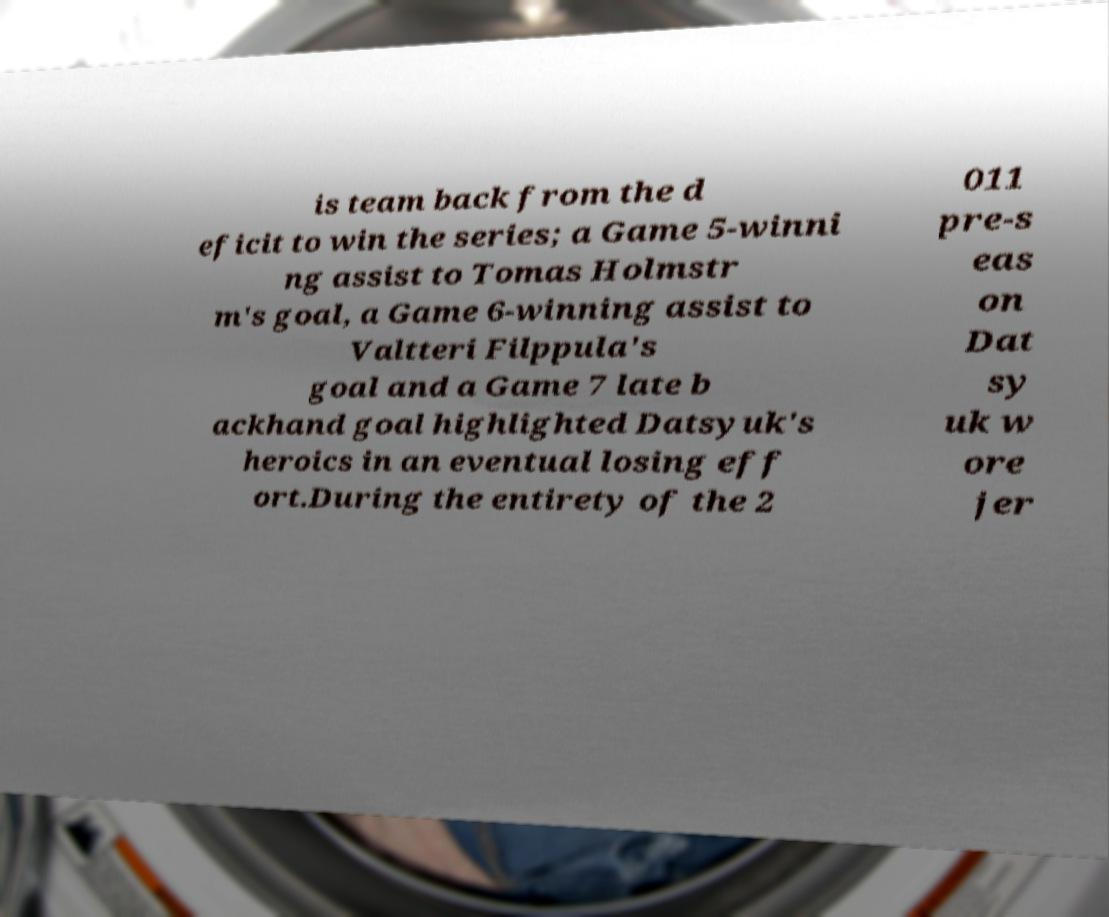Could you assist in decoding the text presented in this image and type it out clearly? is team back from the d eficit to win the series; a Game 5-winni ng assist to Tomas Holmstr m's goal, a Game 6-winning assist to Valtteri Filppula's goal and a Game 7 late b ackhand goal highlighted Datsyuk's heroics in an eventual losing eff ort.During the entirety of the 2 011 pre-s eas on Dat sy uk w ore jer 